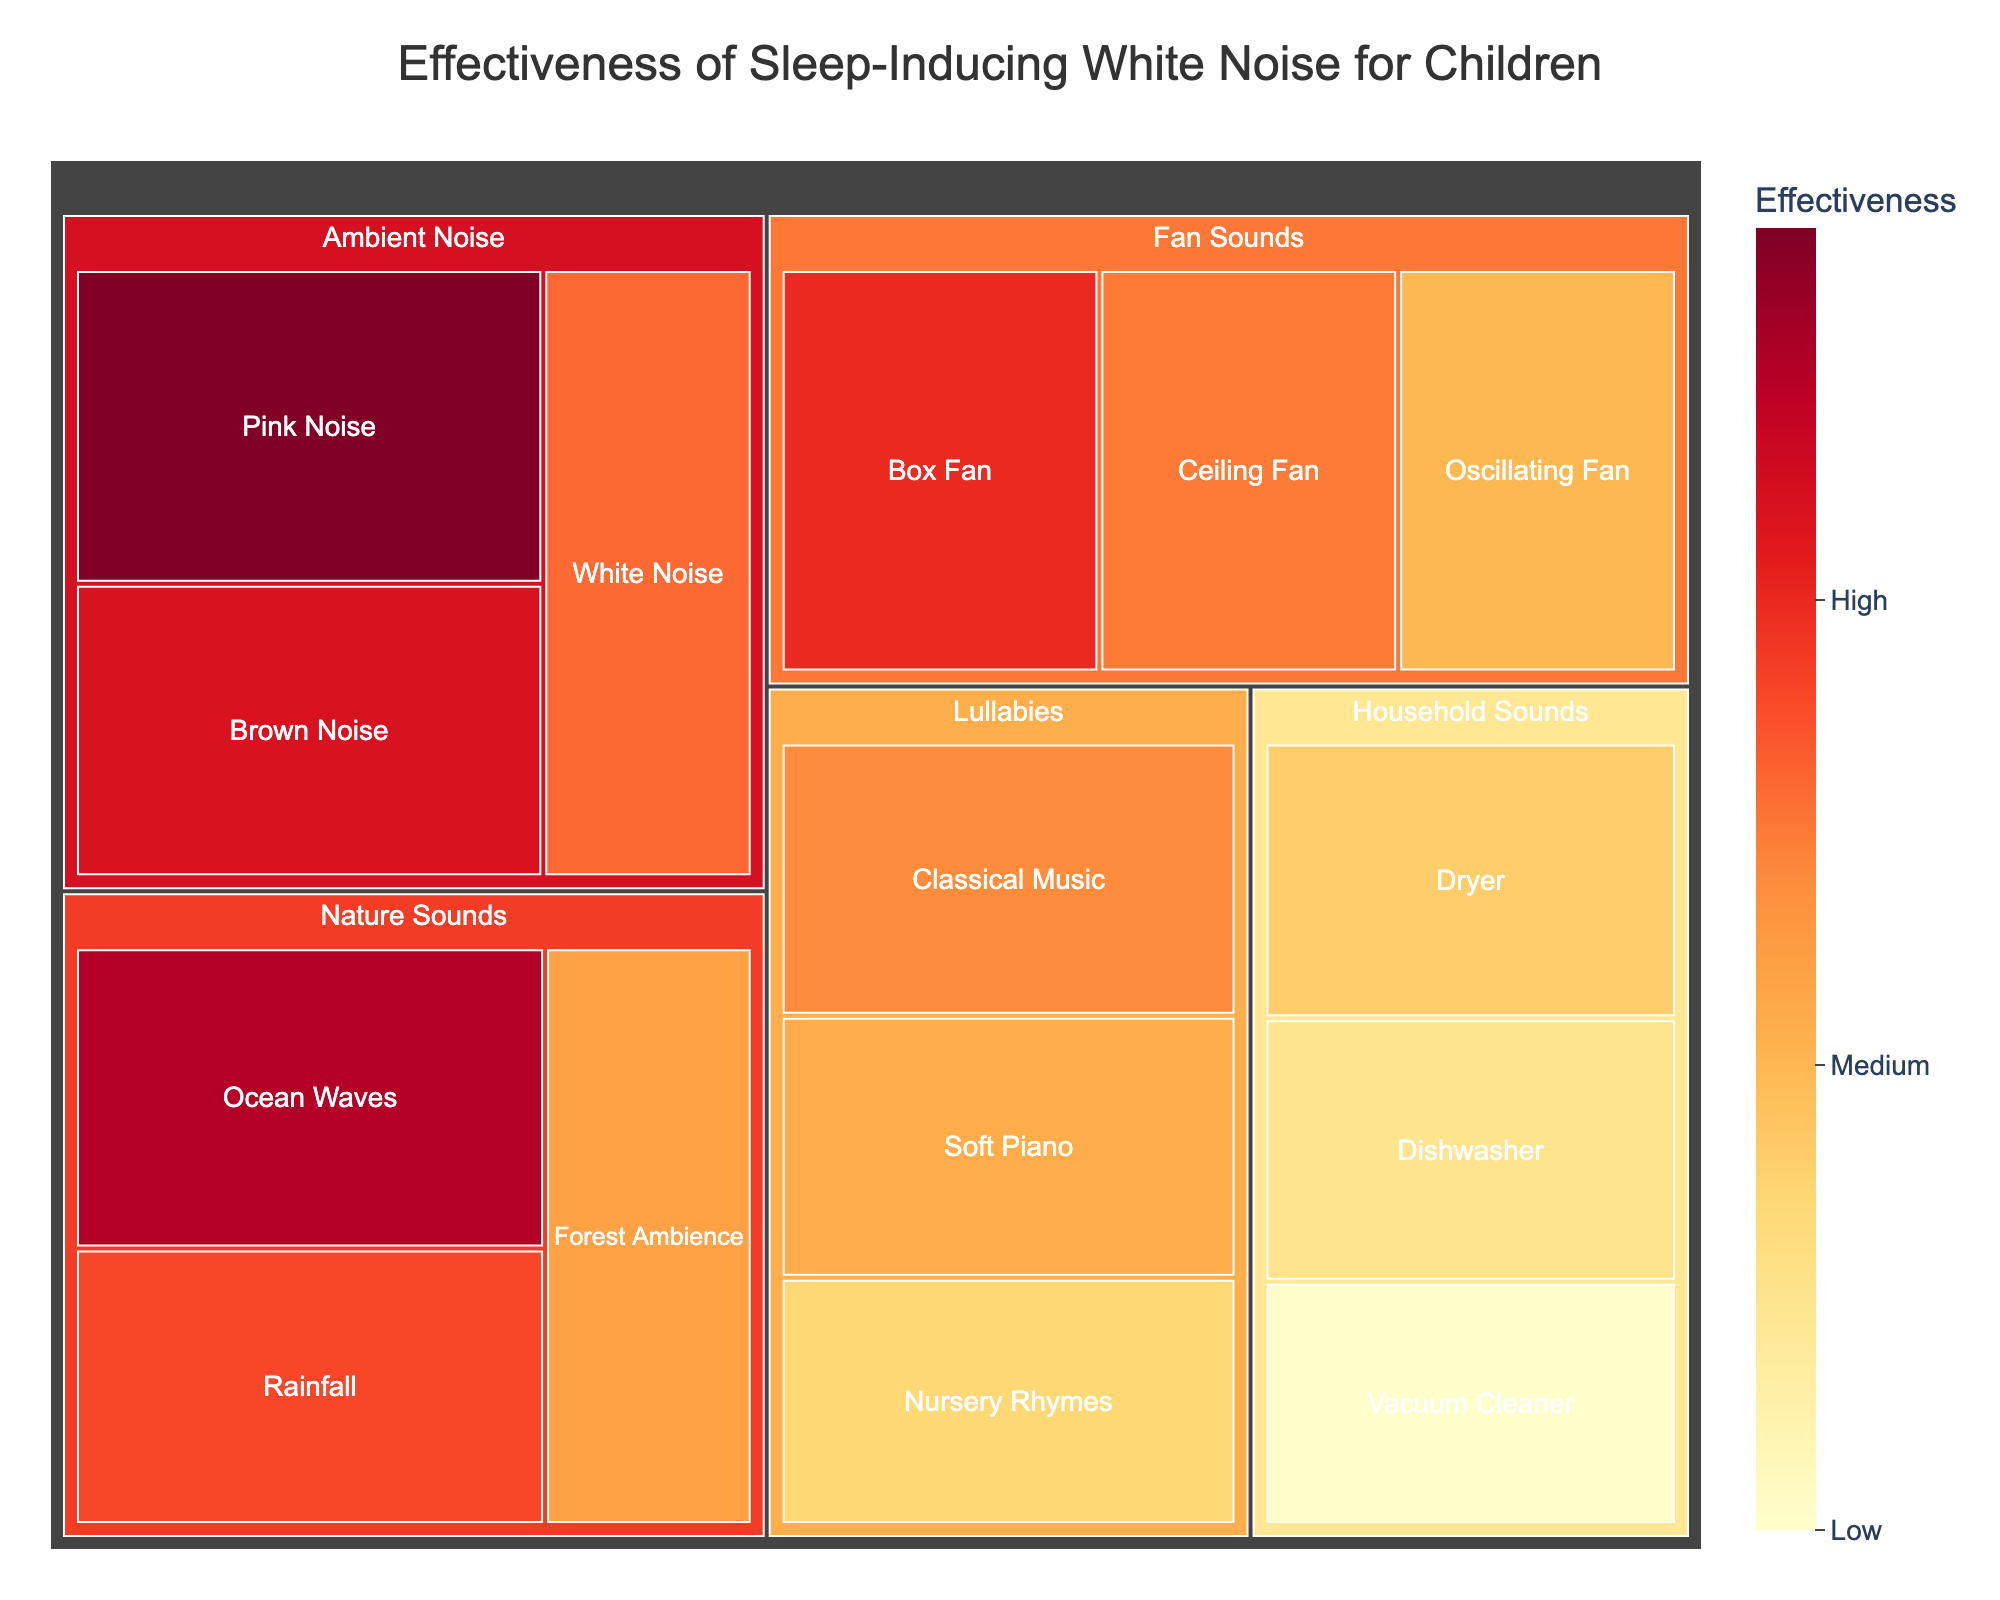what is the title of the treemap? The title is typically found at the top of the figure and it states what the figure is about. In this case, it would be something related to white noise and its effectiveness for children.
Answer: Effectiveness of Sleep-Inducing White Noise for Children Which type of noise under the Nature Sounds category has the highest effectiveness? To find this, look at the Nature Sounds category and identify the type of noise with the highest effectiveness value.
Answer: Ocean Waves What is the effectiveness of the oscillating fan sound? The effectiveness for the oscillating fan sound is given in the Fan Sounds category. Look for the effectiveness value next to Oscillating Fan.
Answer: 70 Compare the effectiveness of Pink Noise and White Noise. Which one is more effective and by how much? Find the effectiveness values for both Pink Noise and White Noise in the Ambient Noise category. Subtract the effectiveness of White Noise from that of Pink Noise to find the difference.
Answer: Pink Noise is more effective by 12 points (88 - 76) Calculate the average effectiveness of the sounds in the Household Sounds category. Add the effectiveness values of Dryer, Dishwasher, and Vacuum Cleaner and divide by three to get the average.
Answer: (68 + 65 + 60) / 3 = 64.33 Which noise type overall has the lowest effectiveness? This requires examining all the noise types across all categories and identifying the one with the lowest effectiveness value.
Answer: Vacuum Cleaner Which category has the highest sum of effectiveness values for its sounds? Sum up the effectiveness values in each category and compare the totals to find the highest one.
Answer: Nature Sounds (85 + 78 + 72 = 235) How much more effective is classical music compared to nursery rhymes? Subtract the effectiveness value of Nursery Rhymes from that of Classical Music, both found under the Lullabies category.
Answer: Classical Music is more effective by 7 points (74 - 67) Which two categories have the closest sum of effectiveness values? Calculate the sum of effectiveness values for each category and compare them to find the two with the smallest difference.
Answer: Lullabies (74 + 71 + 67 = 212) and Household Sounds (68 + 65 + 60 = 193), with a difference of 19 points 